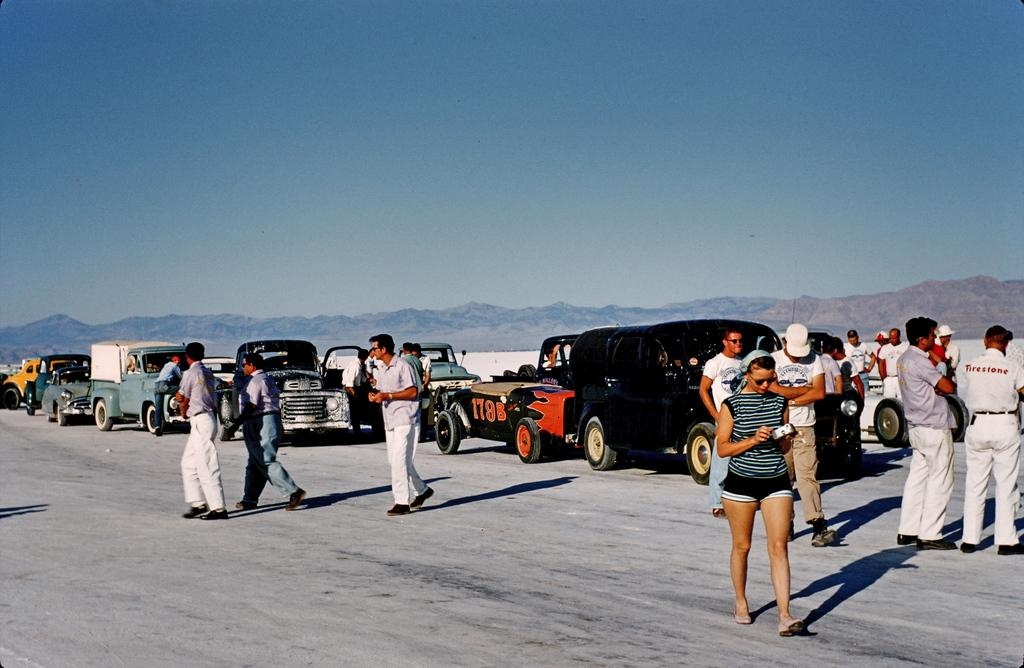What are the people in the image doing? The people in the image are standing on the road. What else can be seen in the image besides the people? There are vehicles and mountains visible in the image. What is visible in the background of the image? The sky is visible in the image. What type of marble is being used to pave the road in the image? There is no marble visible in the image; the road appears to be made of a different material. How many frogs can be seen hopping on the mountains in the image? There are no frogs present in the image; the focus is on the people, vehicles, mountains, and sky. 